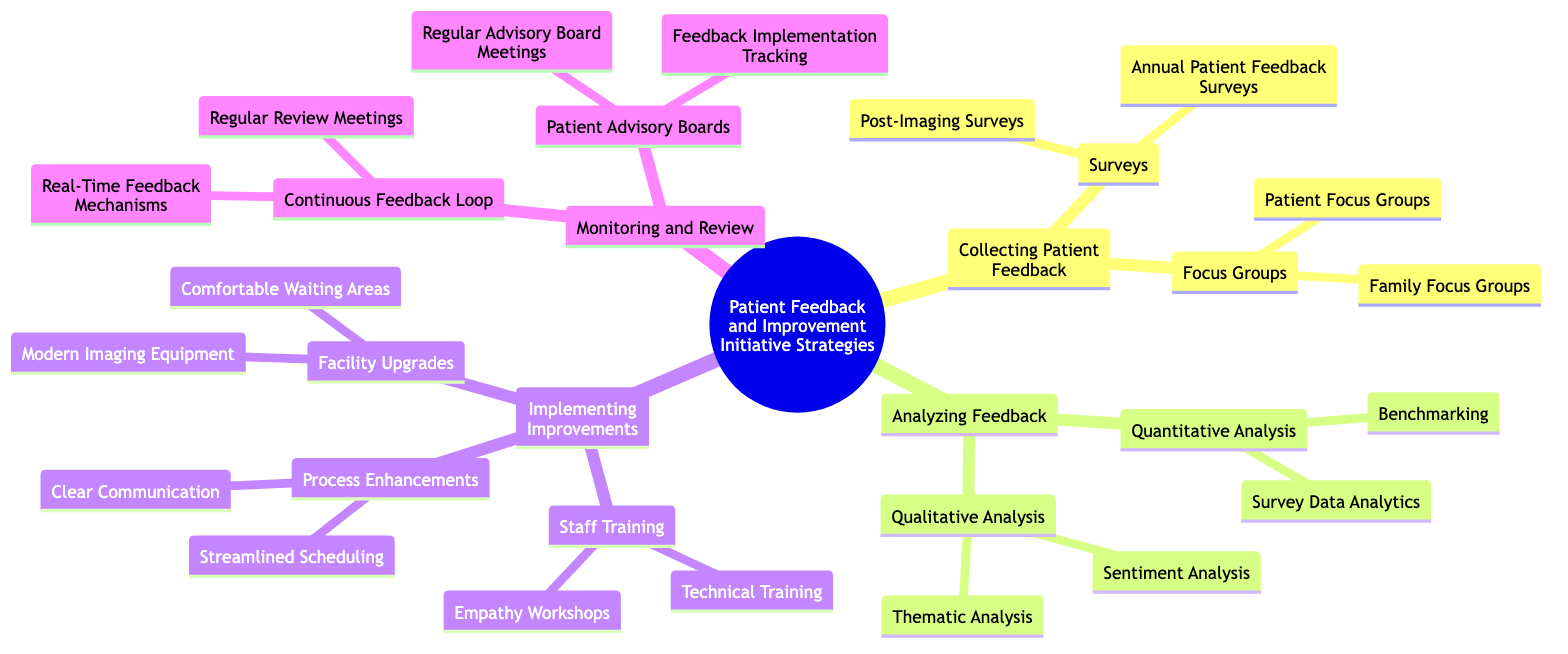What are the two main methods for collecting patient feedback? The diagram shows "Surveys" and "Focus Groups" as two main methods under the "Collecting Patient Feedback" section.
Answer: Surveys, Focus Groups How many types of analysis are mentioned for analyzing feedback? Under the "Analyzing Feedback" section, there are two types: "Quantitative Analysis" and "Qualitative Analysis."
Answer: 2 What is one example of a mechanism for real-time feedback? The diagram lists "Real-Time Feedback Mechanisms" under "Continuous Feedback Loop," with examples inferred from the description.
Answer: Kiosks or apps What type of training aims to enhance empathetic skills of imaging staff? "Empathy Workshops" is listed under "Staff Training" in the "Implementing Improvements" section.
Answer: Empathy Workshops Which two categories are under "Facility Upgrades"? The diagram specifies "Comfortable Waiting Areas" and "Modern Imaging Equipment" under the "Facility Upgrades" implementation strategy.
Answer: Comfortable Waiting Areas, Modern Imaging Equipment What kind of analysis identifies common themes from open-ended survey responses? "Thematic Analysis" is presented under "Qualitative Analysis" in the "Analyzing Feedback" section.
Answer: Thematic Analysis How does benchmarking relate to survey data? Benchmarking is used to compare current patient feedback scores with historical data, which is mentioned under "Quantitative Analysis" in "Analyzing Feedback."
Answer: Comparing with historical data What aspect of monitoring and review involves patient representatives? "Patient Advisory Boards" is the key aspect that involves patient representatives, with activities detailed further.
Answer: Patient Advisory Boards How are the improvements from patient suggestions tracked? "Feedback Implementation Tracking" is mentioned as part of "Patient Advisory Boards" in the "Monitoring and Review" section.
Answer: Feedback Implementation Tracking 